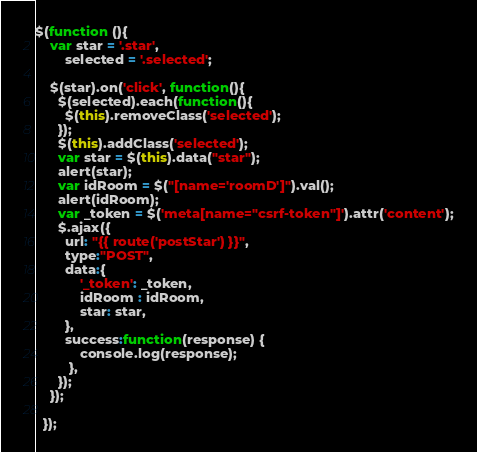<code> <loc_0><loc_0><loc_500><loc_500><_JavaScript_>$(function (){
    var star = '.star',
        selected = '.selected';
    
    $(star).on('click', function(){
      $(selected).each(function(){
        $(this).removeClass('selected');
      });
      $(this).addClass('selected');
      var star = $(this).data("star");
      alert(star);
      var idRoom = $("[name='roomD']").val();
      alert(idRoom);
      var _token = $('meta[name="csrf-token"]').attr('content');
      $.ajax({
        url: "{{ route('postStar') }}",
        type:"POST",
        data:{
            '_token': _token,
            idRoom : idRoom,
            star: star,
        },
        success:function(response) {
            console.log(response);
         },
      });
    });
   
  });</code> 